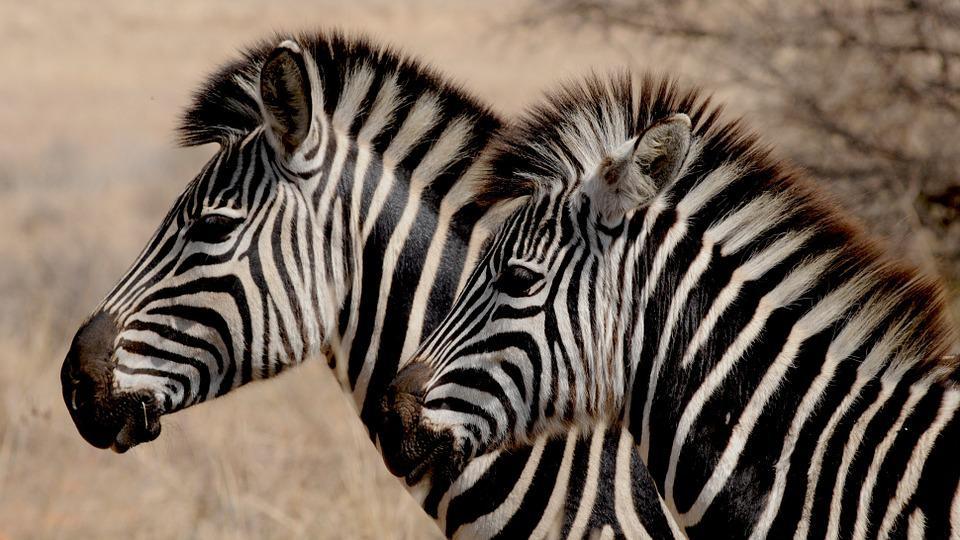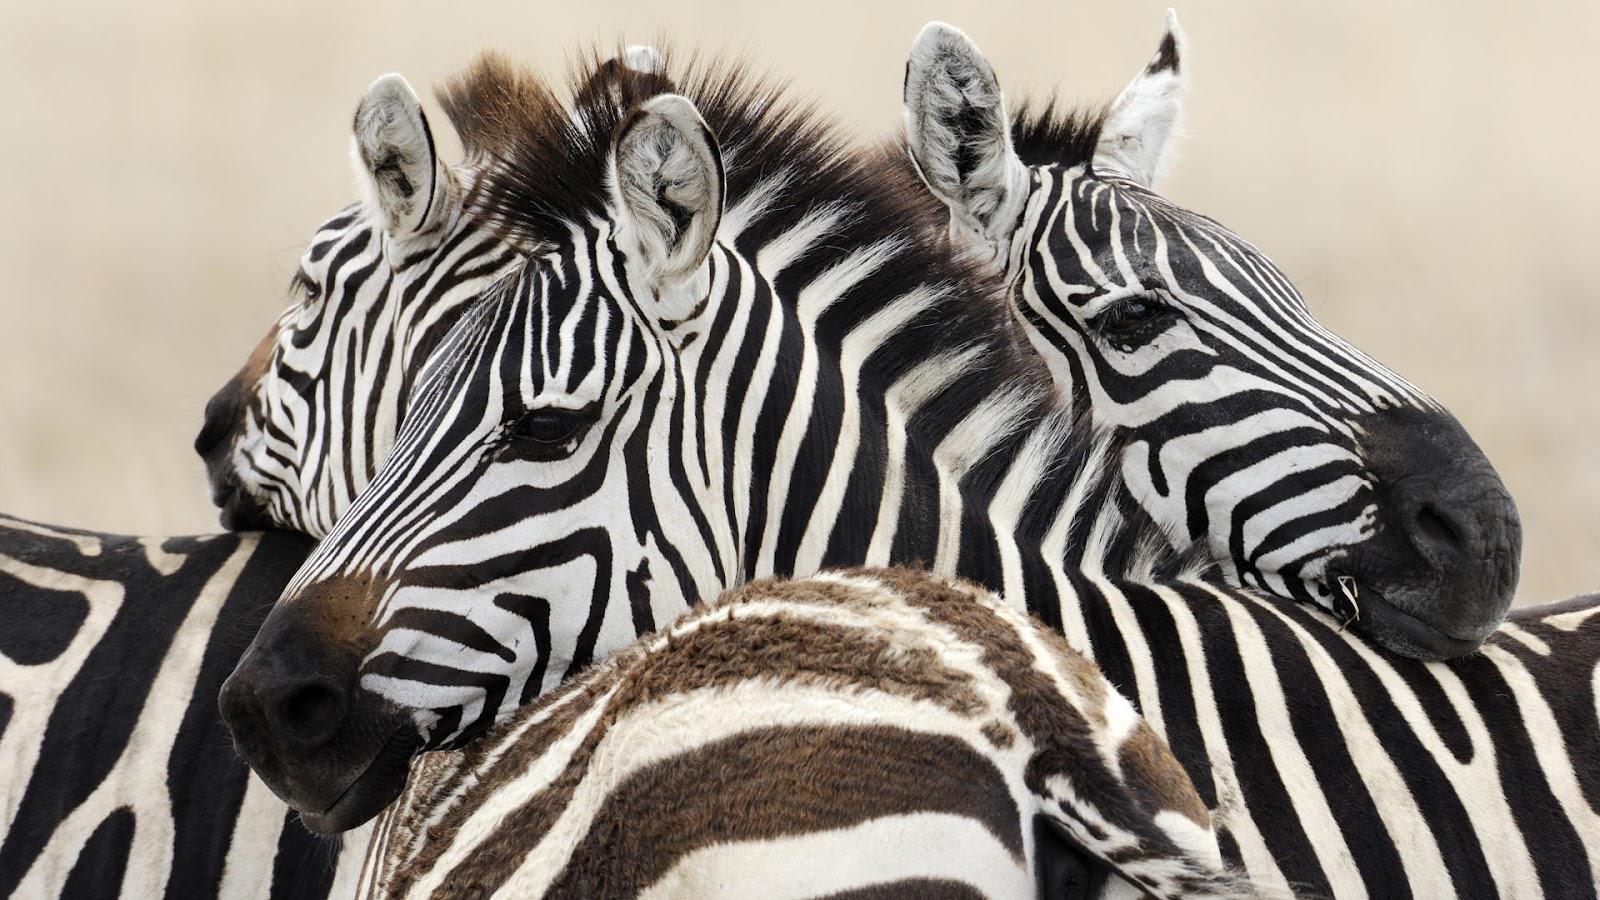The first image is the image on the left, the second image is the image on the right. Examine the images to the left and right. Is the description "At least three zebras in each image are facing the same direction." accurate? Answer yes or no. No. The first image is the image on the left, the second image is the image on the right. Considering the images on both sides, is "Neither image in the pair shows fewer than three zebras." valid? Answer yes or no. No. 